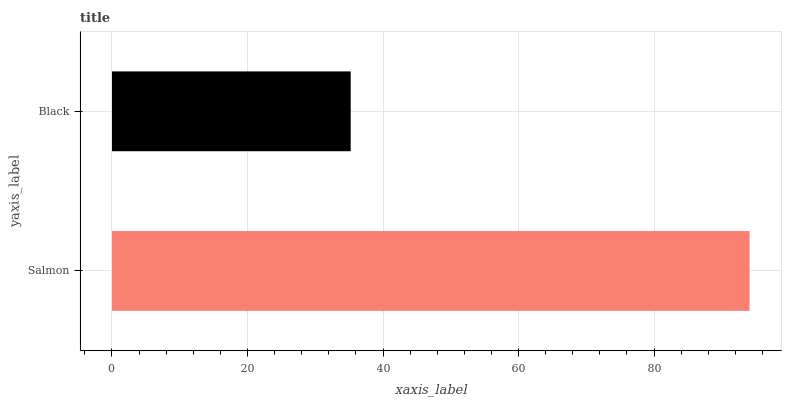Is Black the minimum?
Answer yes or no. Yes. Is Salmon the maximum?
Answer yes or no. Yes. Is Black the maximum?
Answer yes or no. No. Is Salmon greater than Black?
Answer yes or no. Yes. Is Black less than Salmon?
Answer yes or no. Yes. Is Black greater than Salmon?
Answer yes or no. No. Is Salmon less than Black?
Answer yes or no. No. Is Salmon the high median?
Answer yes or no. Yes. Is Black the low median?
Answer yes or no. Yes. Is Black the high median?
Answer yes or no. No. Is Salmon the low median?
Answer yes or no. No. 